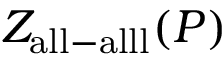Convert formula to latex. <formula><loc_0><loc_0><loc_500><loc_500>Z _ { a l l - a l l l } ( P )</formula> 